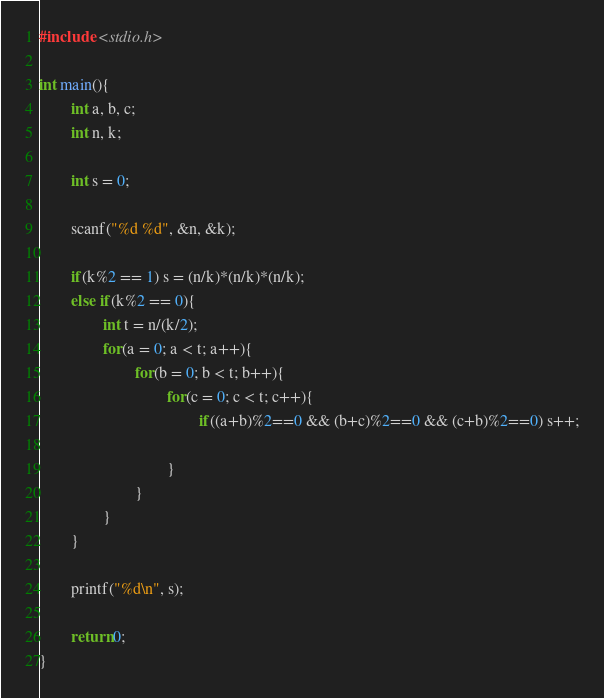Convert code to text. <code><loc_0><loc_0><loc_500><loc_500><_C_>#include <stdio.h>

int main(){ 
        int a, b, c;
        int n, k;

        int s = 0;

        scanf("%d %d", &n, &k);

        if(k%2 == 1) s = (n/k)*(n/k)*(n/k);
        else if(k%2 == 0){
                int t = n/(k/2);
                for(a = 0; a < t; a++){
                        for(b = 0; b < t; b++){
                                for(c = 0; c < t; c++){
                                        if((a+b)%2==0 && (b+c)%2==0 && (c+b)%2==0) s++;
                         
                                }
                        }
                }
        }

        printf("%d\n", s);

        return 0;
}
</code> 